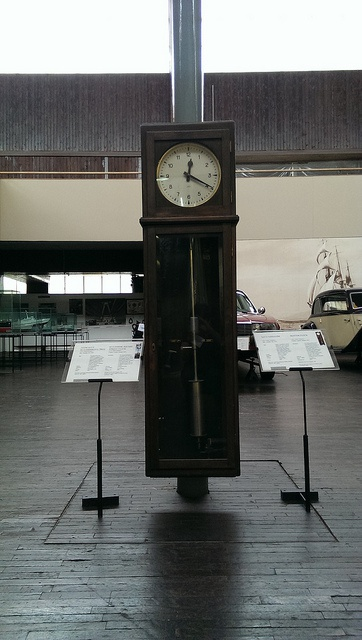Describe the objects in this image and their specific colors. I can see clock in white, darkgray, gray, and black tones, car in white, black, gray, and darkgray tones, car in white, black, gray, darkgray, and lightgray tones, and boat in white, teal, and black tones in this image. 